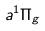Convert formula to latex. <formula><loc_0><loc_0><loc_500><loc_500>a ^ { 1 } \Pi _ { g }</formula> 